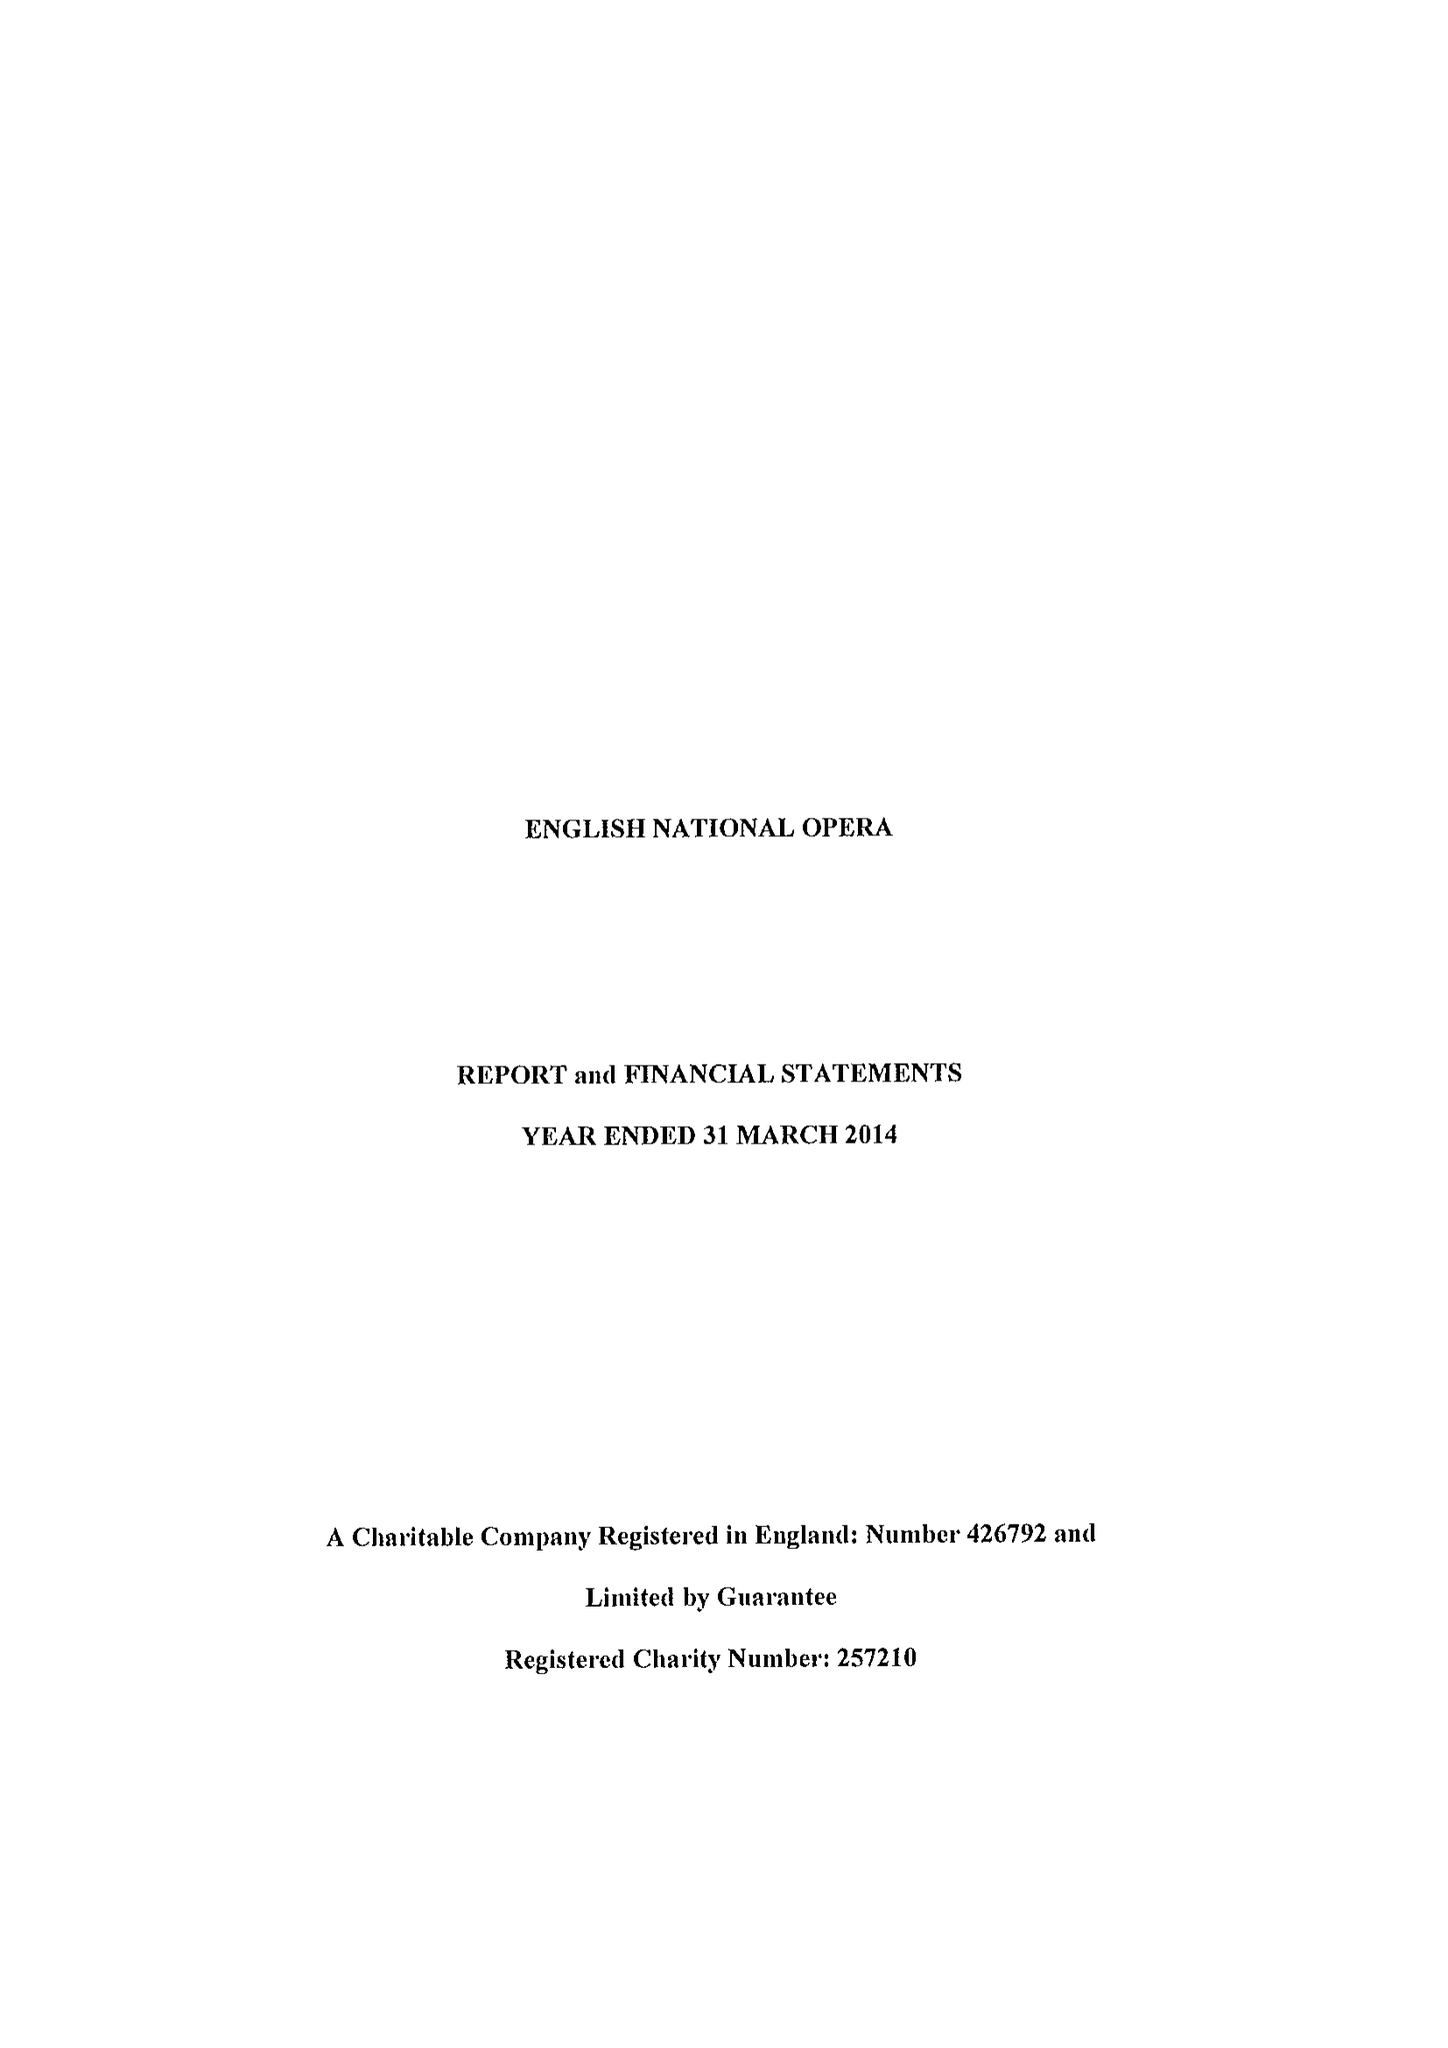What is the value for the income_annually_in_british_pounds?
Answer the question using a single word or phrase. 36967000.00 